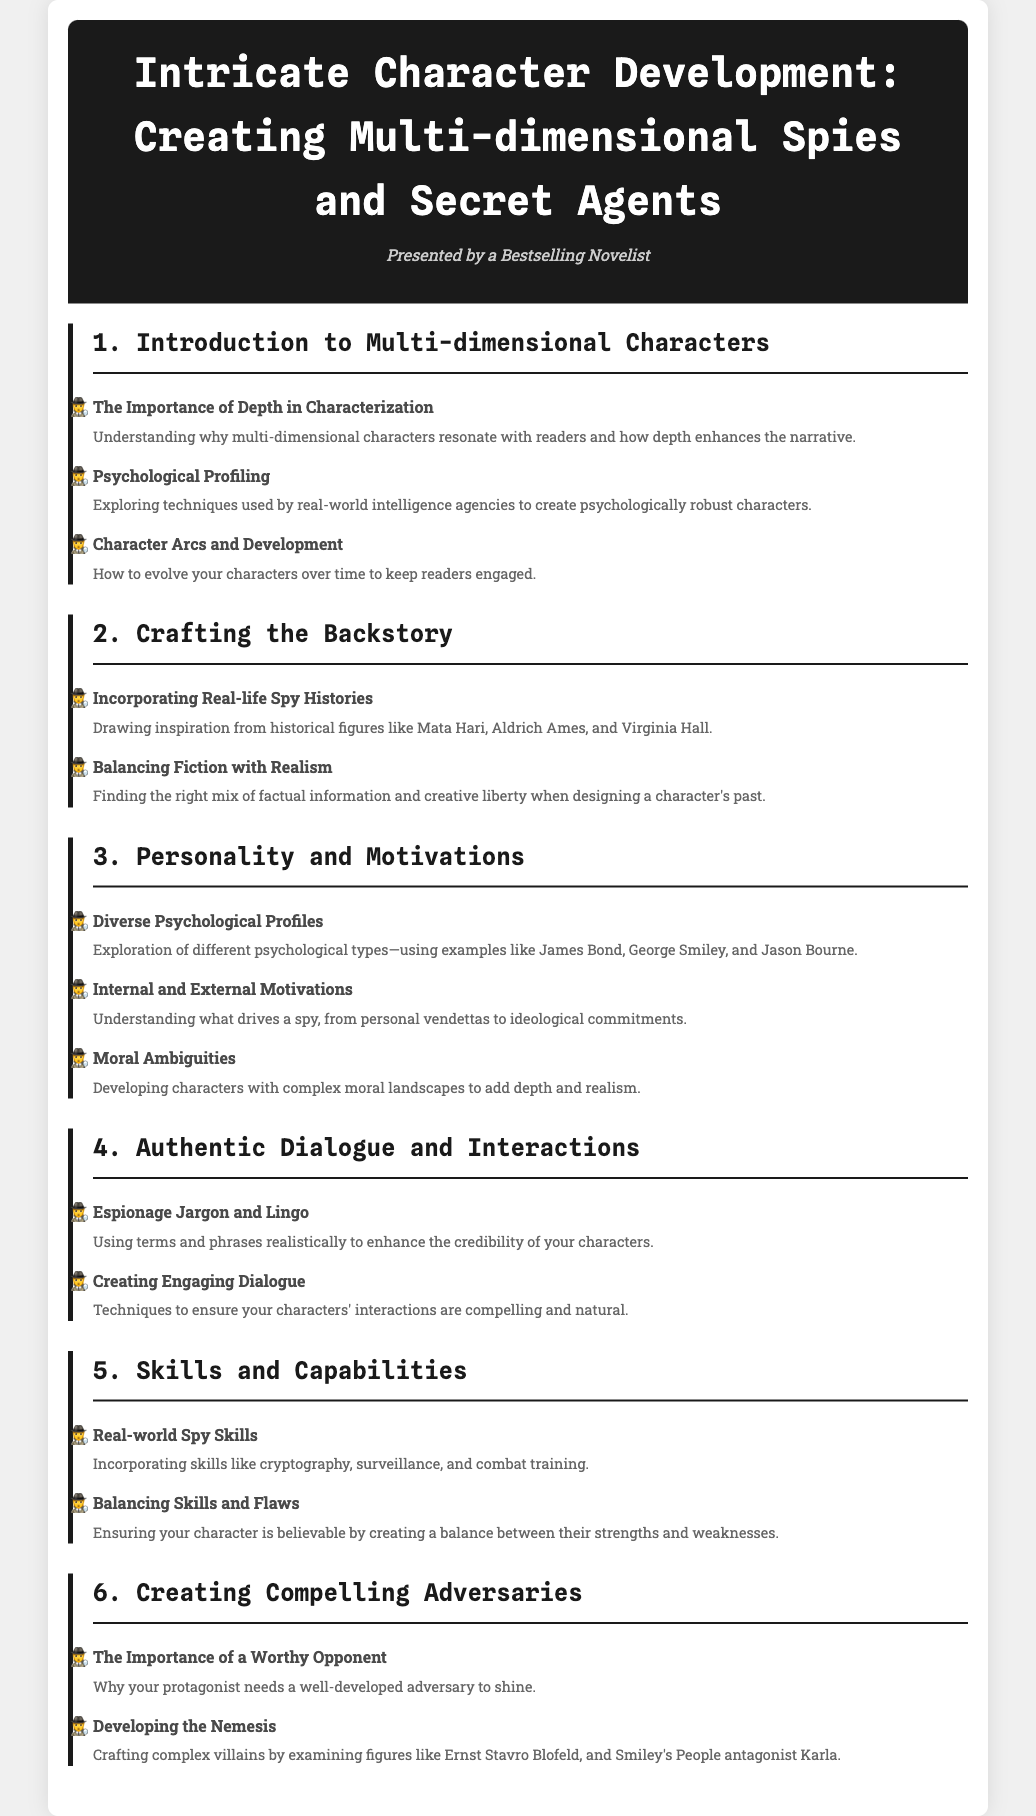what is the title of the syllabus? The title of the syllabus is displayed prominently at the top of the document.
Answer: Intricate Character Development: Creating Multi-dimensional Spies and Secret Agents who is the presenter of the syllabus? The presenter is mentioned under the title, indicating their background.
Answer: Bestselling Novelist how many main modules are in the syllabus? The number of main modules can be counted from the document's structure.
Answer: 6 what is the first topic under "Introduction to Multi-dimensional Characters"? The first topic is listed in the first module section.
Answer: The Importance of Depth in Characterization which historical figure is mentioned in the backstory module? The historical figures referenced provide examples for character backstory.
Answer: Mata Hari what psychological types are mentioned in the "Diverse Psychological Profiles" topic? The examples provided illustrate different psychological profiles within the module.
Answer: James Bond, George Smiley, Jason Bourne what skill category is discussed in the "Skills and Capabilities" module? The module focuses on specific skills related to spies.
Answer: Real-world Spy Skills what is the focus of the "Creating Compelling Adversaries" module? The main emphasis of this module is detailed in the description provided.
Answer: The Importance of a Worthy Opponent 